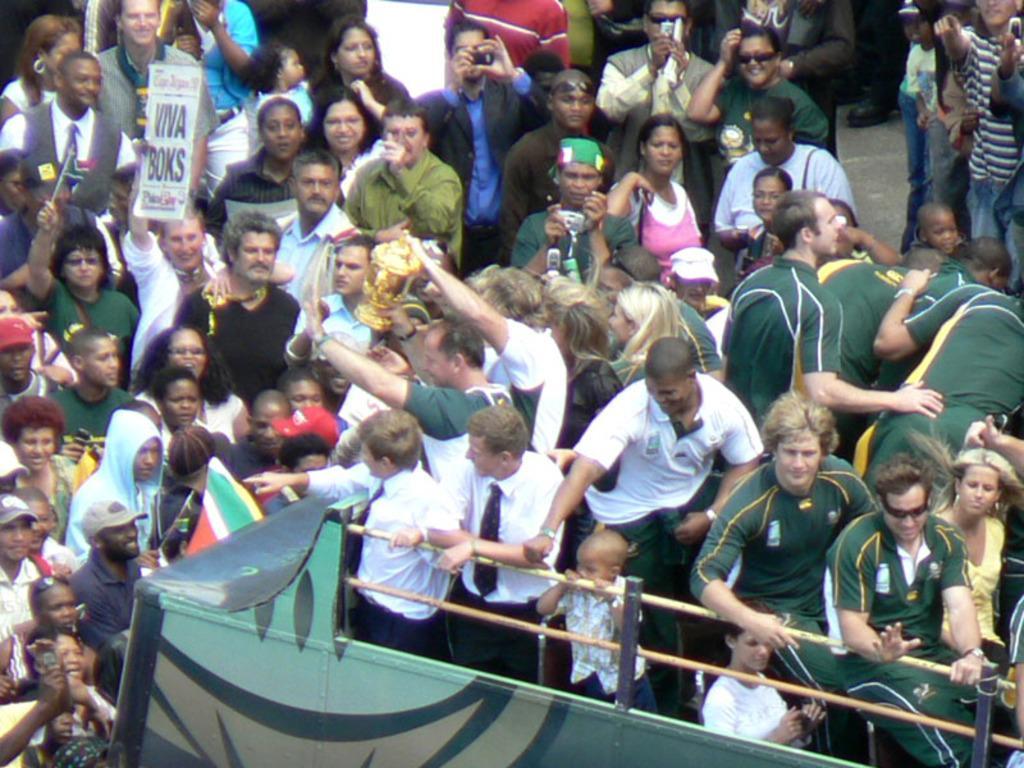Please provide a concise description of this image. In this image I can see there are groups of persons standing and holding an object. And there is a stick attached to the stand. 